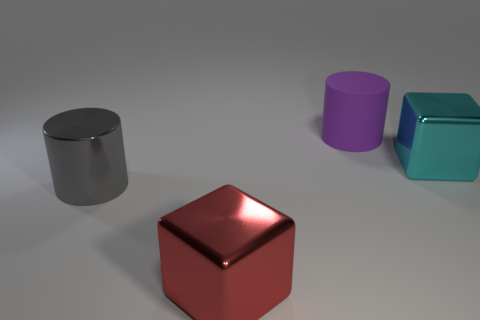There is a large red object; what number of big cubes are behind it?
Offer a very short reply. 1. Do the big gray thing in front of the big purple cylinder and the large object that is behind the big cyan object have the same material?
Keep it short and to the point. No. What number of objects are big shiny things in front of the gray thing or brown balls?
Your response must be concise. 1. Are there fewer large cyan things that are left of the large cyan metal cube than large blocks left of the rubber object?
Your response must be concise. Yes. What number of other objects are the same size as the purple object?
Offer a very short reply. 3. Do the gray cylinder and the big cylinder that is right of the red metallic object have the same material?
Your answer should be very brief. No. What number of things are either big metallic cubes that are behind the big gray cylinder or large metallic cubes on the right side of the red metallic cube?
Provide a short and direct response. 1. The metallic cylinder is what color?
Your response must be concise. Gray. Is the number of big metallic cubes that are behind the large gray metallic cylinder less than the number of large metal objects?
Provide a short and direct response. Yes. Are any small brown rubber things visible?
Give a very brief answer. No. 